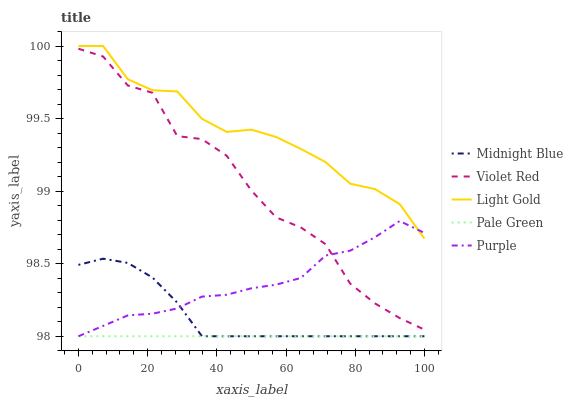Does Pale Green have the minimum area under the curve?
Answer yes or no. Yes. Does Light Gold have the maximum area under the curve?
Answer yes or no. Yes. Does Violet Red have the minimum area under the curve?
Answer yes or no. No. Does Violet Red have the maximum area under the curve?
Answer yes or no. No. Is Pale Green the smoothest?
Answer yes or no. Yes. Is Violet Red the roughest?
Answer yes or no. Yes. Is Violet Red the smoothest?
Answer yes or no. No. Is Pale Green the roughest?
Answer yes or no. No. Does Purple have the lowest value?
Answer yes or no. Yes. Does Violet Red have the lowest value?
Answer yes or no. No. Does Light Gold have the highest value?
Answer yes or no. Yes. Does Violet Red have the highest value?
Answer yes or no. No. Is Midnight Blue less than Violet Red?
Answer yes or no. Yes. Is Violet Red greater than Pale Green?
Answer yes or no. Yes. Does Midnight Blue intersect Pale Green?
Answer yes or no. Yes. Is Midnight Blue less than Pale Green?
Answer yes or no. No. Is Midnight Blue greater than Pale Green?
Answer yes or no. No. Does Midnight Blue intersect Violet Red?
Answer yes or no. No. 